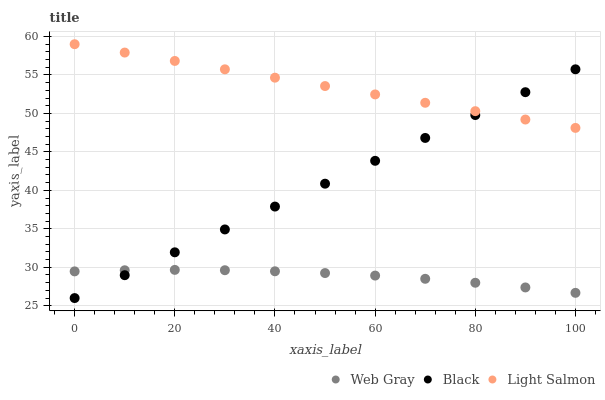Does Web Gray have the minimum area under the curve?
Answer yes or no. Yes. Does Light Salmon have the maximum area under the curve?
Answer yes or no. Yes. Does Black have the minimum area under the curve?
Answer yes or no. No. Does Black have the maximum area under the curve?
Answer yes or no. No. Is Light Salmon the smoothest?
Answer yes or no. Yes. Is Web Gray the roughest?
Answer yes or no. Yes. Is Black the smoothest?
Answer yes or no. No. Is Black the roughest?
Answer yes or no. No. Does Black have the lowest value?
Answer yes or no. Yes. Does Web Gray have the lowest value?
Answer yes or no. No. Does Light Salmon have the highest value?
Answer yes or no. Yes. Does Black have the highest value?
Answer yes or no. No. Is Web Gray less than Light Salmon?
Answer yes or no. Yes. Is Light Salmon greater than Web Gray?
Answer yes or no. Yes. Does Web Gray intersect Black?
Answer yes or no. Yes. Is Web Gray less than Black?
Answer yes or no. No. Is Web Gray greater than Black?
Answer yes or no. No. Does Web Gray intersect Light Salmon?
Answer yes or no. No. 